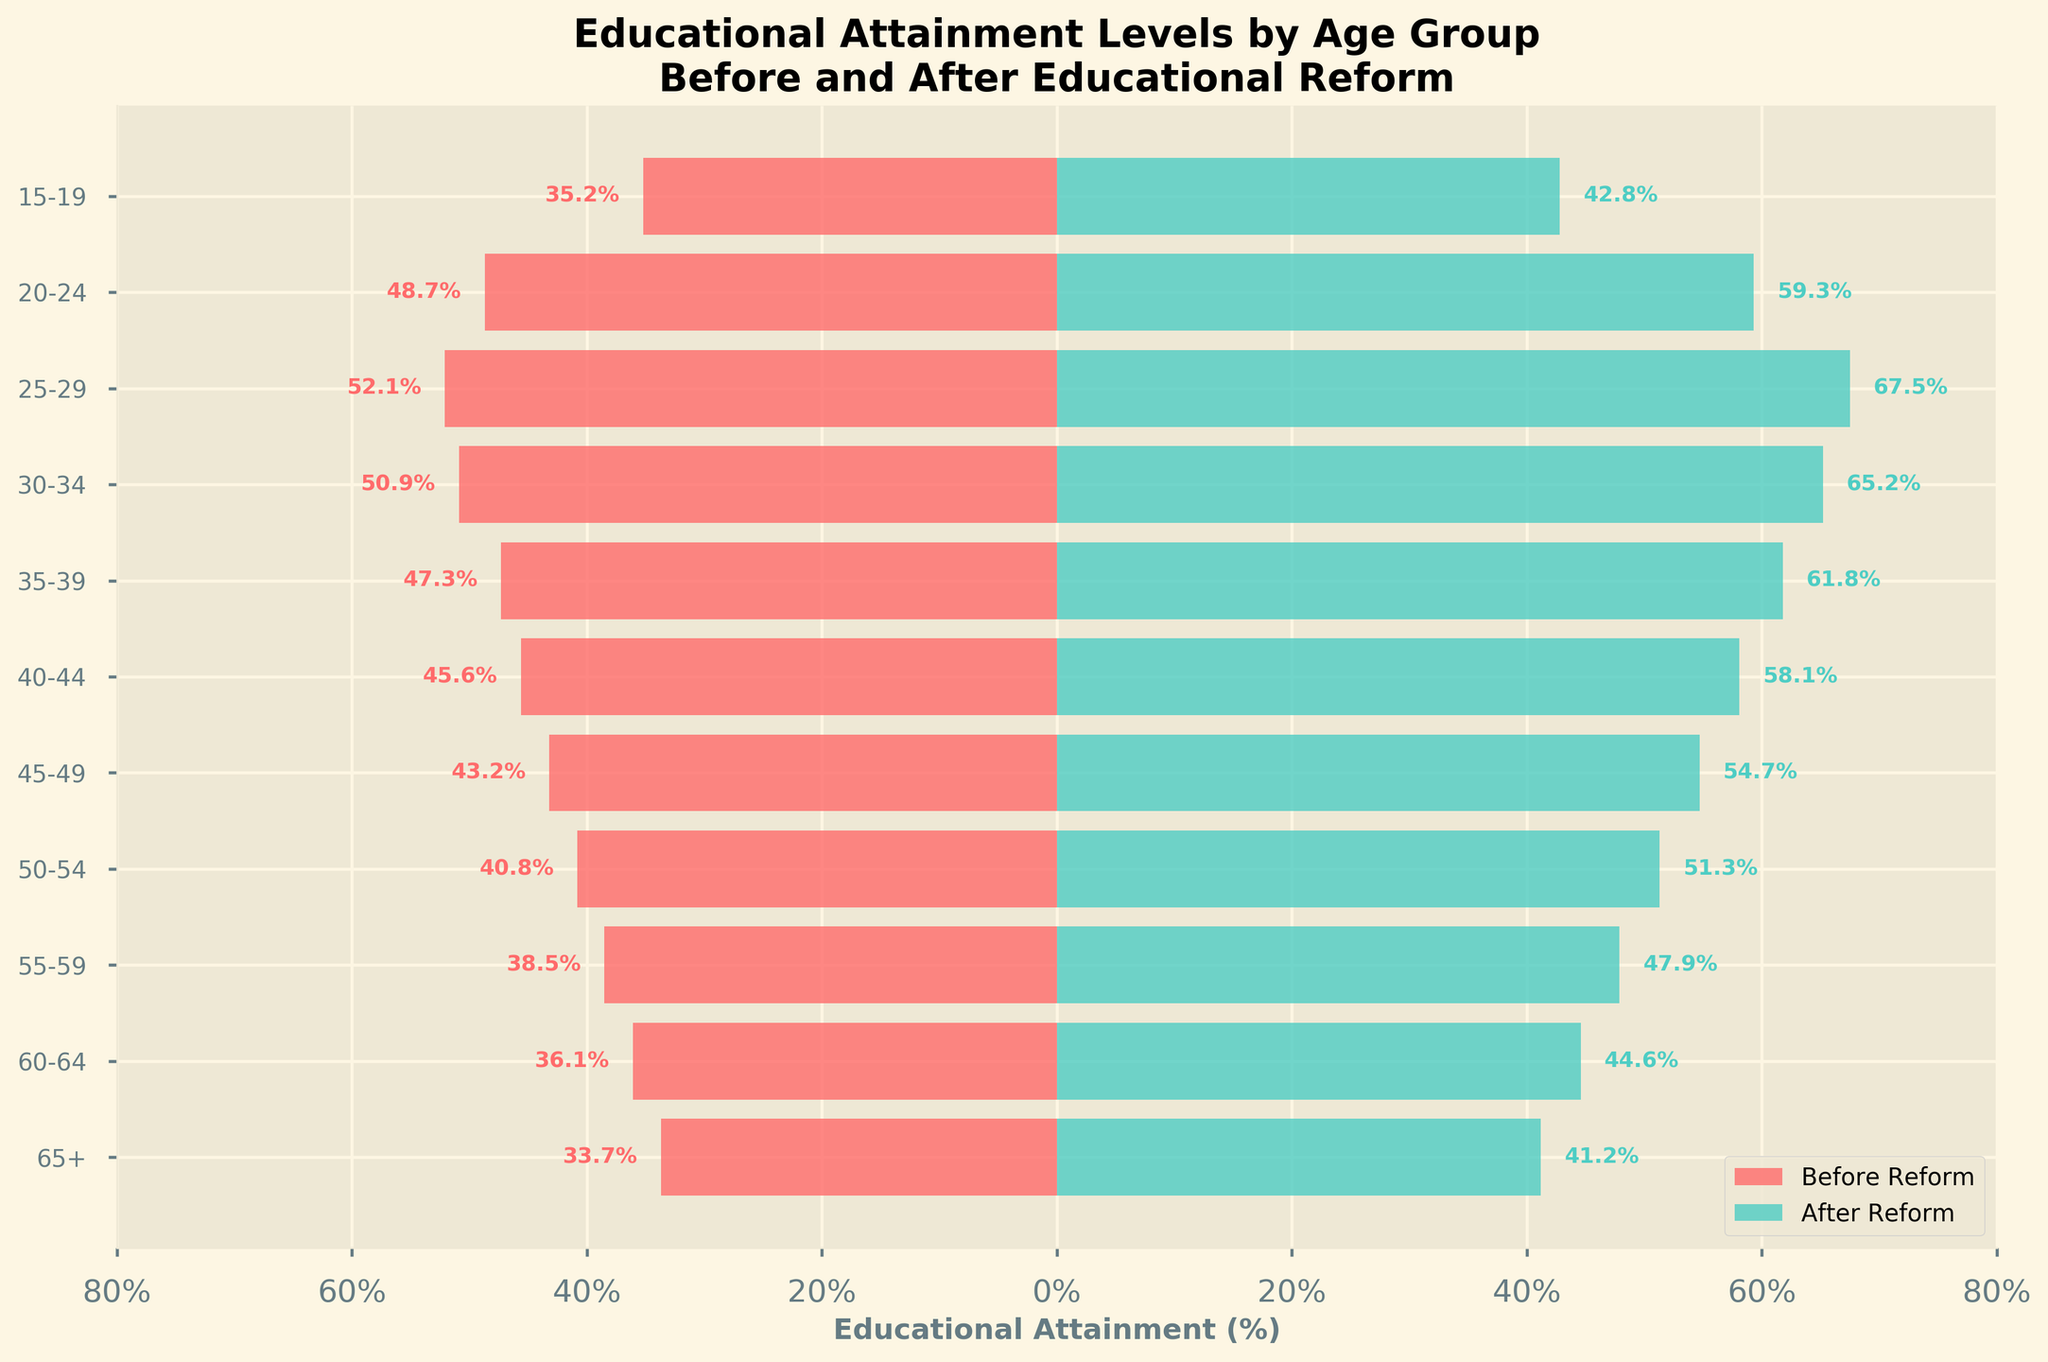What is the title of the figure? The title is usually located at the top of the figure and provides a brief description of what the figure represents. In this case, it states the focus on educational attainment levels before and after a reform.
Answer: Educational Attainment Levels by Age Group Before and After Educational Reform What are the age groups compared in the figure? The age groups are represented on the y-axis and are listed from youngest to oldest: 15-19, 20-24, 25-29, 30-34, 35-39, 40-44, 45-49, 50-54, 55-59, 60-64, 65+.
Answer: 15-19, 20-24, 25-29, 30-34, 35-39, 40-44, 45-49, 50-54, 55-59, 60-64, 65+ Which age group shows the largest increase in educational attainment after the reform? To find the largest increase, look at the difference between the "Before Reform" and "After Reform" percentages for each age group. The 25-29 age group has the largest increase from 52.1% to 67.5%.
Answer: 25-29 Which age group has the lowest educational attainment before the reform? To find the lowest educational attainment before the reform, look at the smallest value in the "Before Reform" percentage column. The 65+ age group has the lowest attainment at 33.7%.
Answer: 65+ What percentage did the 30-34 age group attain after the reform? The educational attainment percentage for the 30-34 age group after the reform is found in the "After Reform" column. It is 65.2%.
Answer: 65.2% Compare the educational attainment of the 40-44 age group before and after the reform. For the 40-44 age group, the attainment was 45.6% before the reform and 58.1% after the reform. To compare, subtract the before value from the after value: 58.1 - 45.6 = 12.5.
Answer: 12.5% What is the average educational attainment after the reform across all age groups? To find the average, sum up the educational attainment percentages for all age groups after the reform and divide by the number of age groups: (42.8 + 59.3 + 67.5 + 65.2 + 61.8 + 58.1 + 54.7 + 51.3 + 47.9 + 44.6 + 41.2) / 11 = 55.85.
Answer: 55.85% Which age group has the smallest change in educational attainment after the reform? To find the smallest change, calculate the difference between the "Before Reform" and "After Reform" percentages for each age group, then look for the smallest value. The 65+ age group has the smallest change: 41.2 - 33.7 = 7.5.
Answer: 65+ By how much did the educational attainment of the 55-59 age group improve? The improvement for the 55-59 age group is the difference between the "After Reform" and "Before Reform" percentages: 47.9 - 38.5 = 9.4.
Answer: 9.4% What is the total sum of percentages for all age groups before the reform? Sum up the educational attainment percentages for all age groups before the reform: 35.2 + 48.7 + 52.1 + 50.9 + 47.3 + 45.6 + 43.2 + 40.8 + 38.5 + 36.1 + 33.7 = 472.1.
Answer: 472.1 